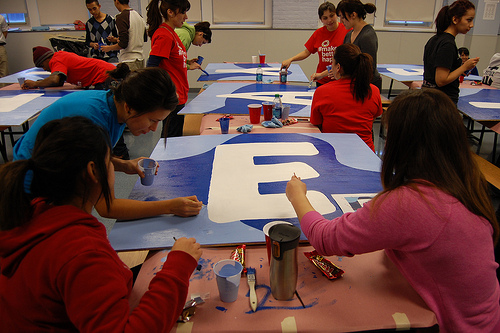<image>
Is there a girl to the left of the girl? No. The girl is not to the left of the girl. From this viewpoint, they have a different horizontal relationship. 